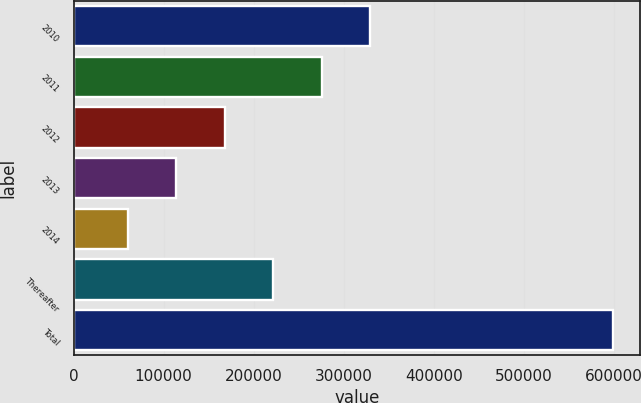Convert chart. <chart><loc_0><loc_0><loc_500><loc_500><bar_chart><fcel>2010<fcel>2011<fcel>2012<fcel>2013<fcel>2014<fcel>Thereafter<fcel>Total<nl><fcel>329394<fcel>275490<fcel>167683<fcel>113779<fcel>59875<fcel>221586<fcel>598913<nl></chart> 